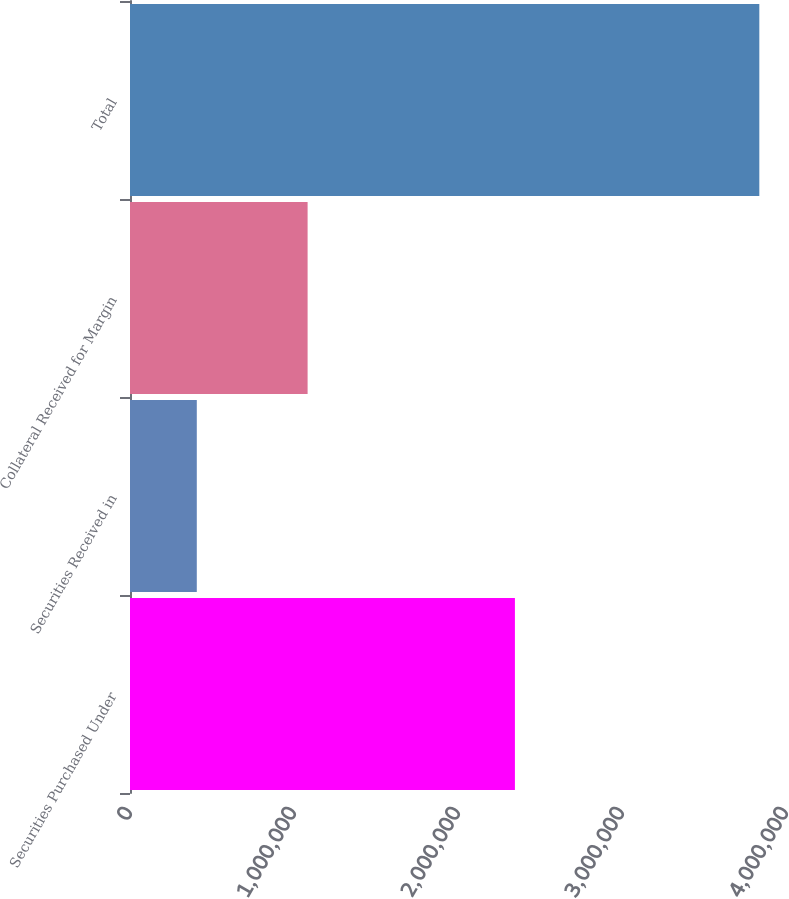Convert chart to OTSL. <chart><loc_0><loc_0><loc_500><loc_500><bar_chart><fcel>Securities Purchased Under<fcel>Securities Received in<fcel>Collateral Received for Margin<fcel>Total<nl><fcel>2.34707e+06<fcel>407314<fcel>1.08291e+06<fcel>3.8373e+06<nl></chart> 